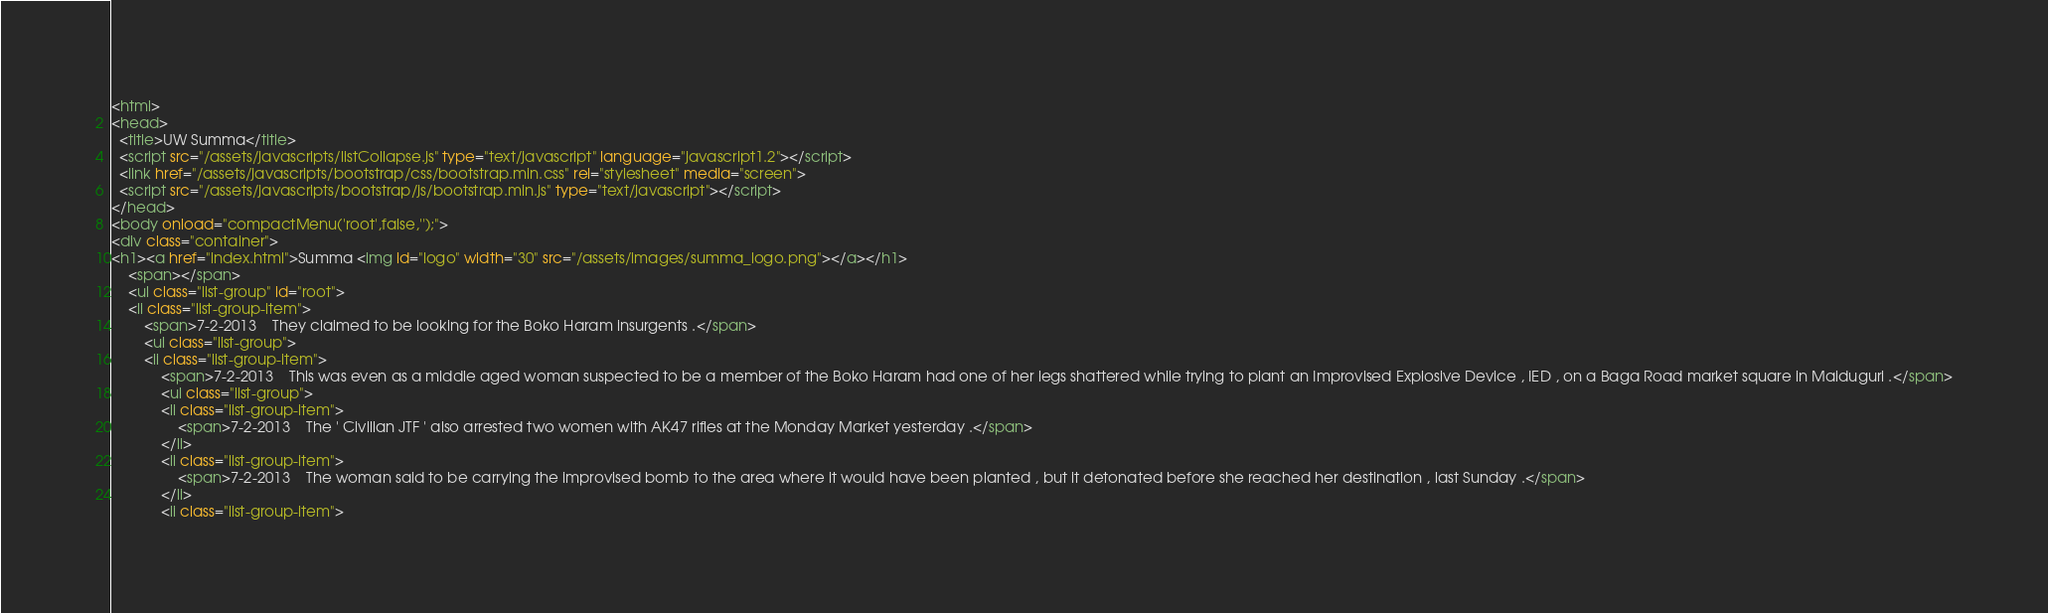<code> <loc_0><loc_0><loc_500><loc_500><_HTML_>
<html>
<head>
  <title>UW Summa</title>
  <script src="/assets/javascripts/listCollapse.js" type="text/javascript" language="javascript1.2"></script>
  <link href="/assets/javascripts/bootstrap/css/bootstrap.min.css" rel="stylesheet" media="screen">
  <script src="/assets/javascripts/bootstrap/js/bootstrap.min.js" type="text/javascript"></script>
</head>
<body onload="compactMenu('root',false,'');">
<div class="container">
<h1><a href="index.html">Summa <img id="logo" width="30" src="/assets/images/summa_logo.png"></a></h1>
	<span></span>
	<ul class="list-group" id="root">
	<li class="list-group-item">
		<span>7-2-2013	They claimed to be looking for the Boko Haram insurgents .</span>
		<ul class="list-group">
		<li class="list-group-item">
			<span>7-2-2013	This was even as a middle aged woman suspected to be a member of the Boko Haram had one of her legs shattered while trying to plant an Improvised Explosive Device , IED , on a Baga Road market square in Maiduguri .</span>
			<ul class="list-group">
			<li class="list-group-item">
				<span>7-2-2013	The ' Civilian JTF ' also arrested two women with AK47 rifles at the Monday Market yesterday .</span>
			</li>
			<li class="list-group-item">
				<span>7-2-2013	The woman said to be carrying the improvised bomb to the area where it would have been planted , but it detonated before she reached her destination , last Sunday .</span>
			</li>
			<li class="list-group-item"></code> 